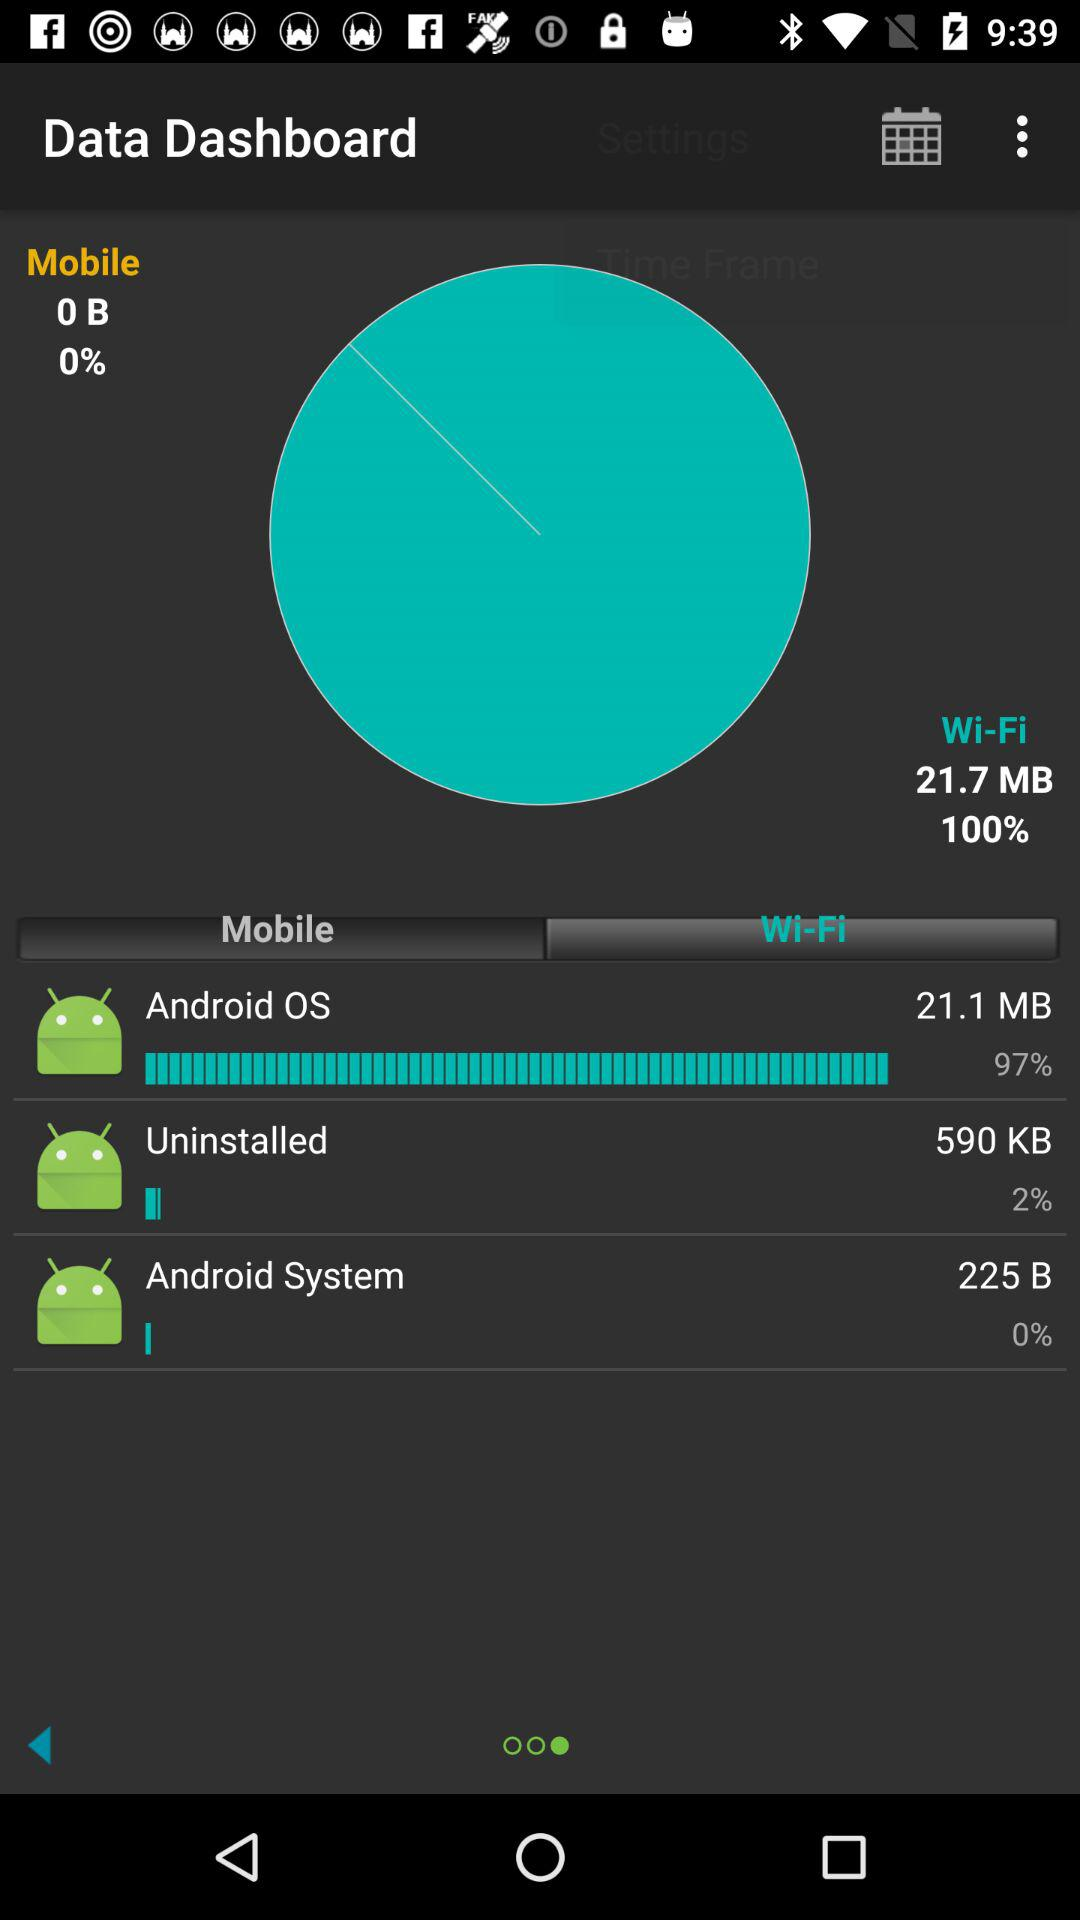How much data is consumed by the Android OS over WiFi in MB? The Android OS has consumed 21.1 MB of data over WiFi. 